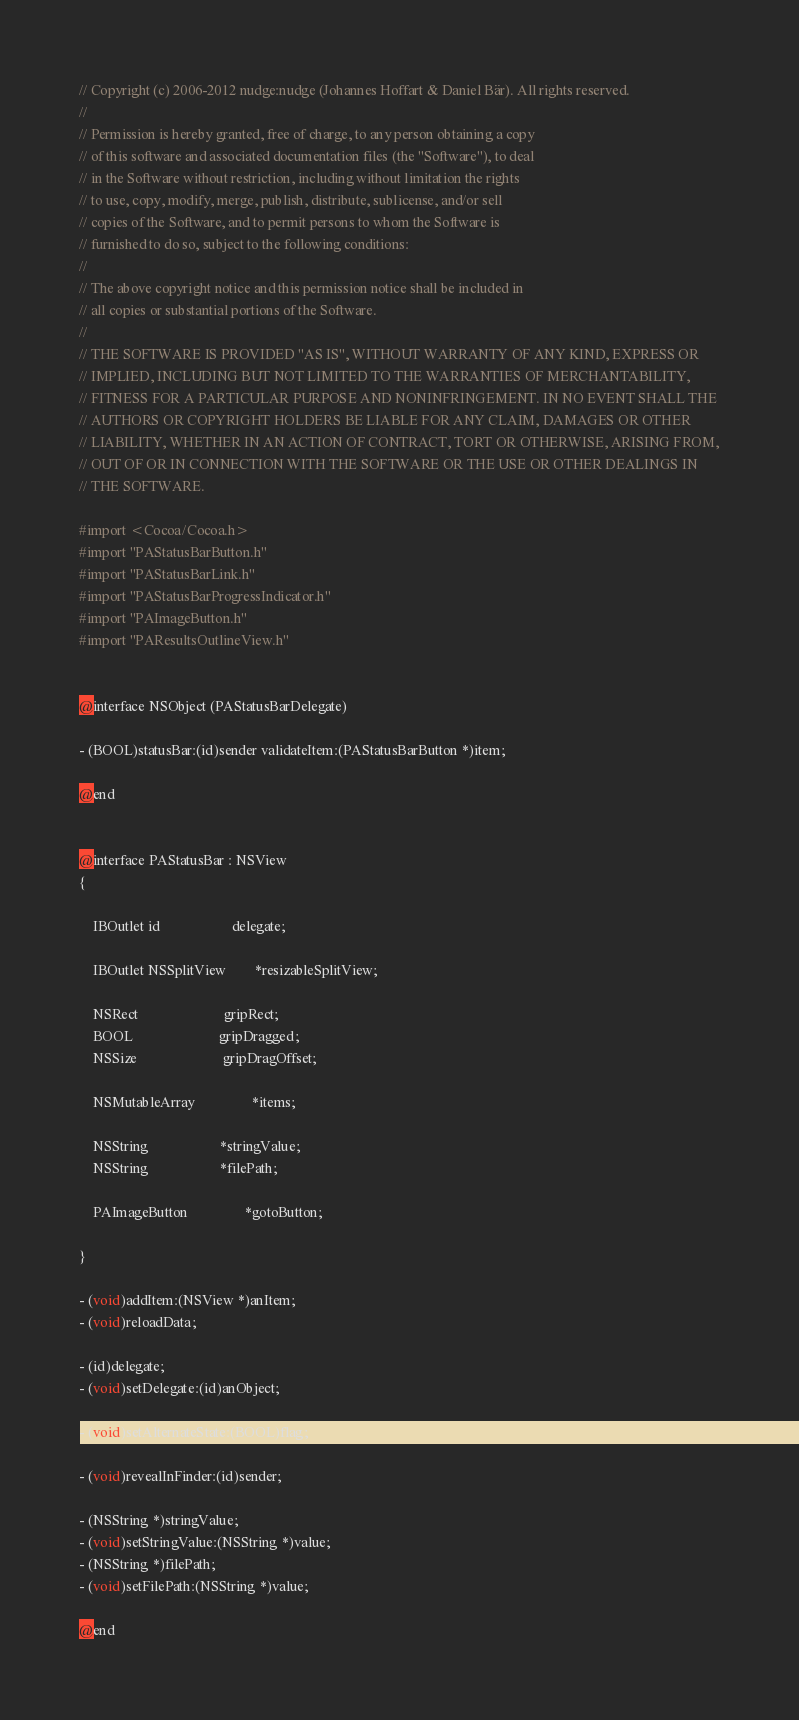<code> <loc_0><loc_0><loc_500><loc_500><_C_>// Copyright (c) 2006-2012 nudge:nudge (Johannes Hoffart & Daniel Bär). All rights reserved.
// 
// Permission is hereby granted, free of charge, to any person obtaining a copy
// of this software and associated documentation files (the "Software"), to deal
// in the Software without restriction, including without limitation the rights
// to use, copy, modify, merge, publish, distribute, sublicense, and/or sell
// copies of the Software, and to permit persons to whom the Software is
// furnished to do so, subject to the following conditions:
// 
// The above copyright notice and this permission notice shall be included in
// all copies or substantial portions of the Software.
// 
// THE SOFTWARE IS PROVIDED "AS IS", WITHOUT WARRANTY OF ANY KIND, EXPRESS OR
// IMPLIED, INCLUDING BUT NOT LIMITED TO THE WARRANTIES OF MERCHANTABILITY,
// FITNESS FOR A PARTICULAR PURPOSE AND NONINFRINGEMENT. IN NO EVENT SHALL THE
// AUTHORS OR COPYRIGHT HOLDERS BE LIABLE FOR ANY CLAIM, DAMAGES OR OTHER
// LIABILITY, WHETHER IN AN ACTION OF CONTRACT, TORT OR OTHERWISE, ARISING FROM,
// OUT OF OR IN CONNECTION WITH THE SOFTWARE OR THE USE OR OTHER DEALINGS IN
// THE SOFTWARE.

#import <Cocoa/Cocoa.h>
#import "PAStatusBarButton.h"
#import "PAStatusBarLink.h"
#import "PAStatusBarProgressIndicator.h"
#import "PAImageButton.h"
#import "PAResultsOutlineView.h"


@interface NSObject (PAStatusBarDelegate)

- (BOOL)statusBar:(id)sender validateItem:(PAStatusBarButton *)item;

@end


@interface PAStatusBar : NSView
{

	IBOutlet id					delegate;
	
	IBOutlet NSSplitView		*resizableSplitView;
	
	NSRect						gripRect;
	BOOL						gripDragged;
	NSSize						gripDragOffset;
	
	NSMutableArray				*items;
	
	NSString					*stringValue;
	NSString					*filePath;
	
	PAImageButton				*gotoButton;
	
}

- (void)addItem:(NSView *)anItem;
- (void)reloadData;

- (id)delegate;
- (void)setDelegate:(id)anObject;

- (void)setAlternateState:(BOOL)flag;

- (void)revealInFinder:(id)sender;

- (NSString *)stringValue;
- (void)setStringValue:(NSString *)value;
- (NSString *)filePath;
- (void)setFilePath:(NSString *)value;

@end
</code> 